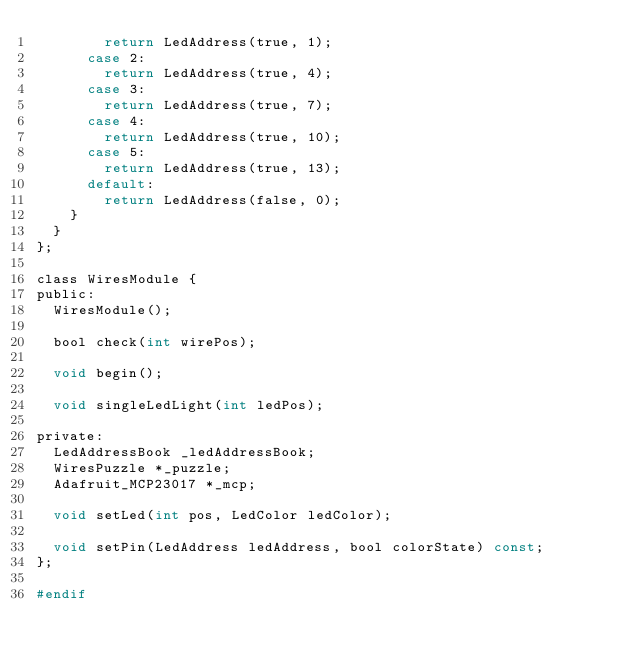<code> <loc_0><loc_0><loc_500><loc_500><_C_>        return LedAddress(true, 1);
      case 2:
        return LedAddress(true, 4);
      case 3:
        return LedAddress(true, 7);
      case 4:
        return LedAddress(true, 10);
      case 5:
        return LedAddress(true, 13);
      default:
        return LedAddress(false, 0);
    }
  }
};

class WiresModule {
public:
  WiresModule();

  bool check(int wirePos);

  void begin();

  void singleLedLight(int ledPos);

private:
  LedAddressBook _ledAddressBook;
  WiresPuzzle *_puzzle;
  Adafruit_MCP23017 *_mcp;

  void setLed(int pos, LedColor ledColor);

  void setPin(LedAddress ledAddress, bool colorState) const;
};

#endif
</code> 